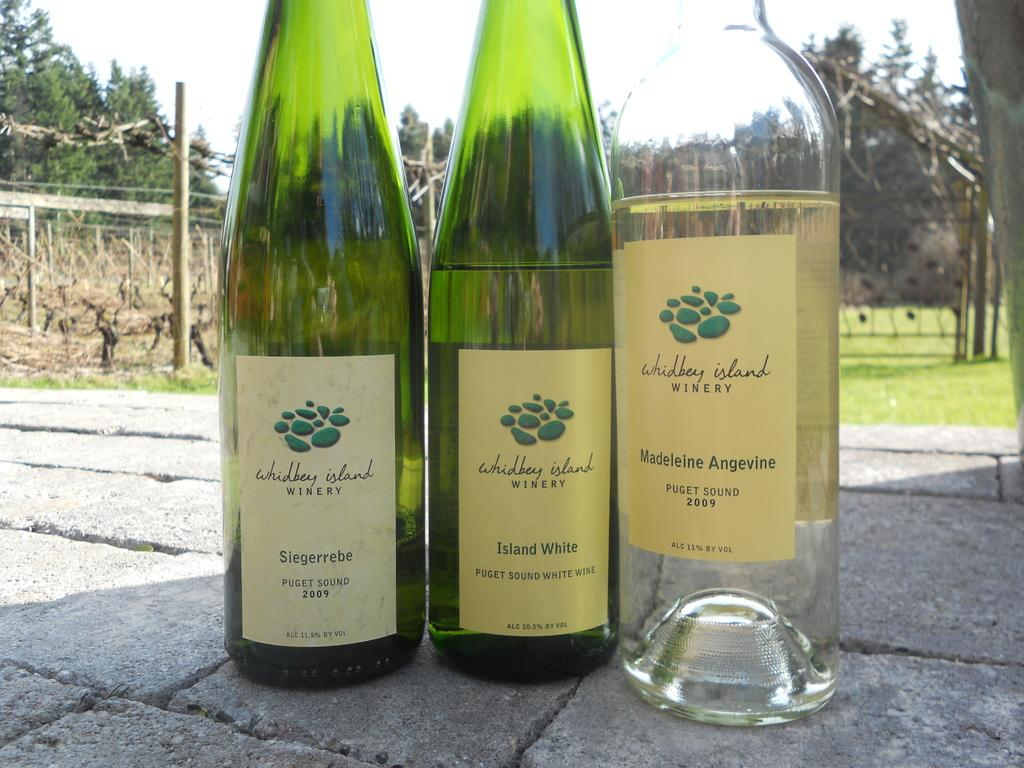<image>
Offer a succinct explanation of the picture presented. Three wine bottles are from Whidbey Island Winery. 